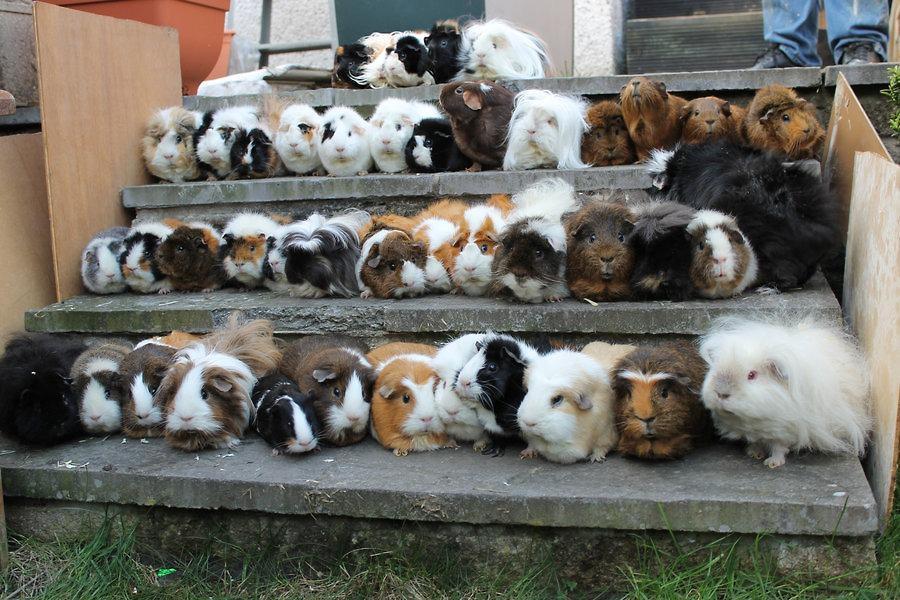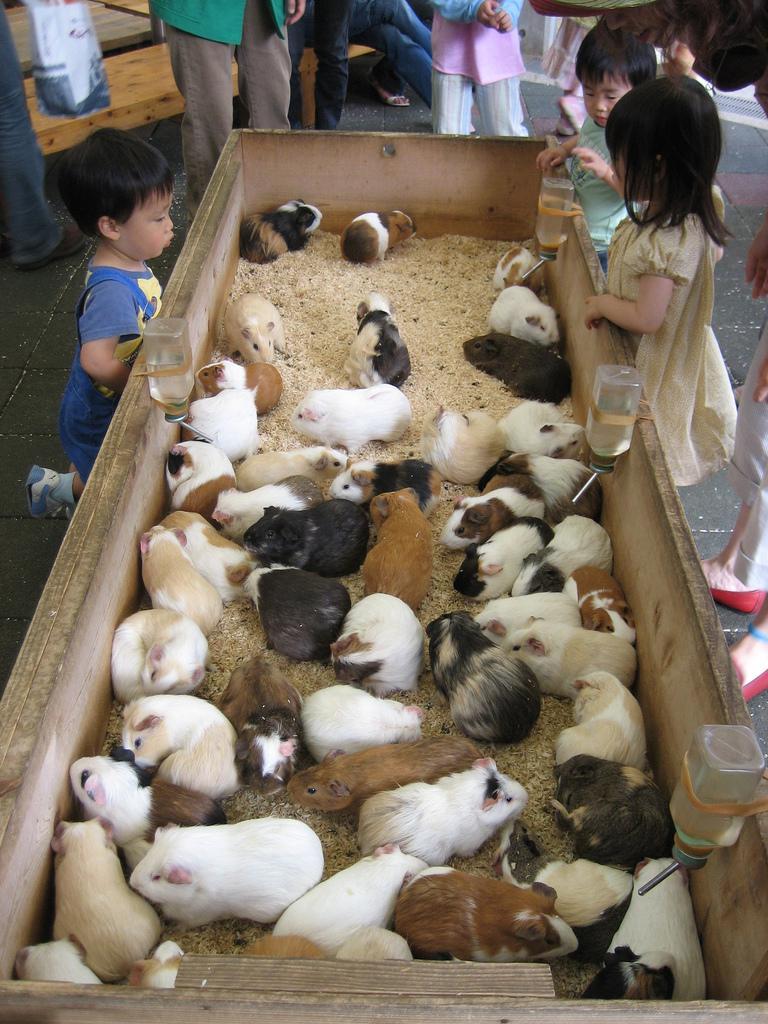The first image is the image on the left, the second image is the image on the right. Evaluate the accuracy of this statement regarding the images: "At least one image features at least six guinea pigs.". Is it true? Answer yes or no. Yes. The first image is the image on the left, the second image is the image on the right. For the images displayed, is the sentence "There are no more than 4 guinea pigs." factually correct? Answer yes or no. No. The first image is the image on the left, the second image is the image on the right. Given the left and right images, does the statement "There are exactly two animals in the image on the left." hold true? Answer yes or no. No. 